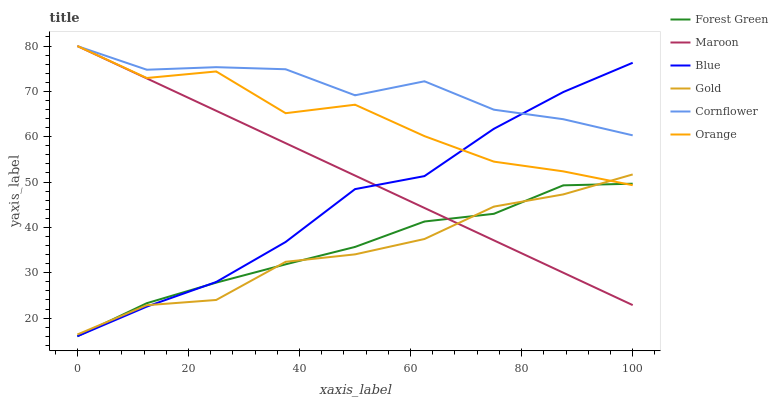Does Gold have the minimum area under the curve?
Answer yes or no. Yes. Does Cornflower have the maximum area under the curve?
Answer yes or no. Yes. Does Cornflower have the minimum area under the curve?
Answer yes or no. No. Does Gold have the maximum area under the curve?
Answer yes or no. No. Is Maroon the smoothest?
Answer yes or no. Yes. Is Orange the roughest?
Answer yes or no. Yes. Is Cornflower the smoothest?
Answer yes or no. No. Is Cornflower the roughest?
Answer yes or no. No. Does Blue have the lowest value?
Answer yes or no. Yes. Does Gold have the lowest value?
Answer yes or no. No. Does Orange have the highest value?
Answer yes or no. Yes. Does Cornflower have the highest value?
Answer yes or no. No. Is Gold less than Cornflower?
Answer yes or no. Yes. Is Cornflower greater than Gold?
Answer yes or no. Yes. Does Blue intersect Cornflower?
Answer yes or no. Yes. Is Blue less than Cornflower?
Answer yes or no. No. Is Blue greater than Cornflower?
Answer yes or no. No. Does Gold intersect Cornflower?
Answer yes or no. No. 